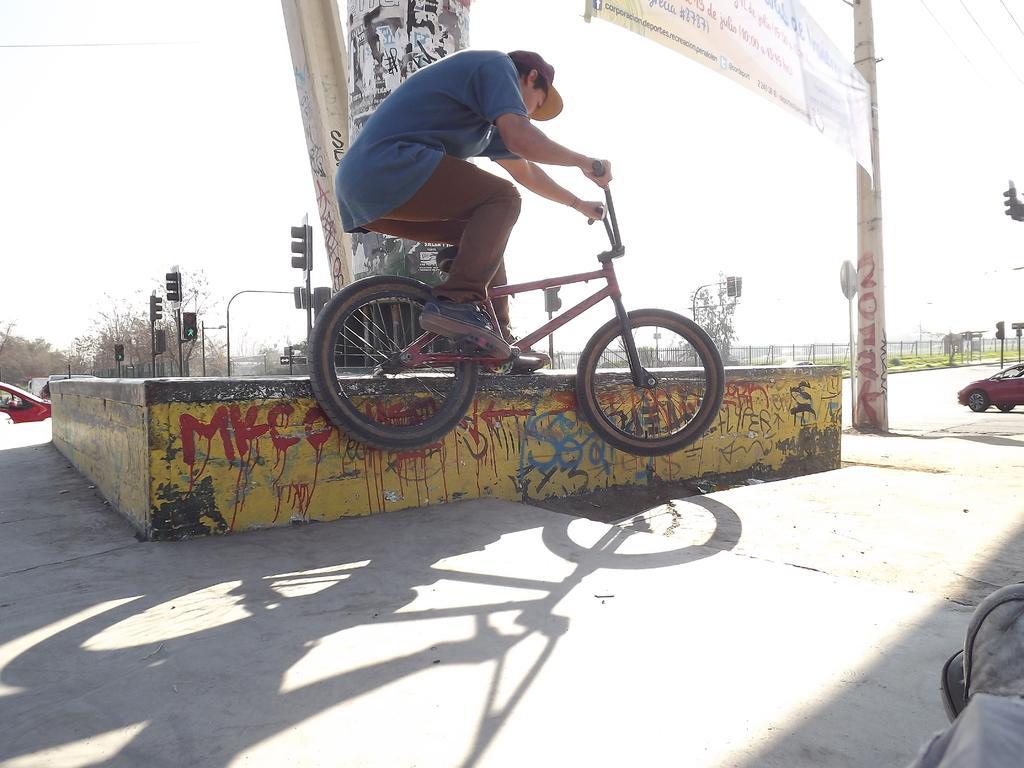Please provide a concise description of this image. Completely an outdoor picture. This man is sitting on a bicycle and holding handle. This is pole with banner. Vehicles on road. Far there are trees and signal lights. 